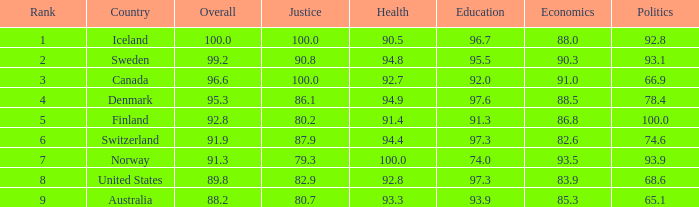What's the health score with justice being 80.7 93.3. 